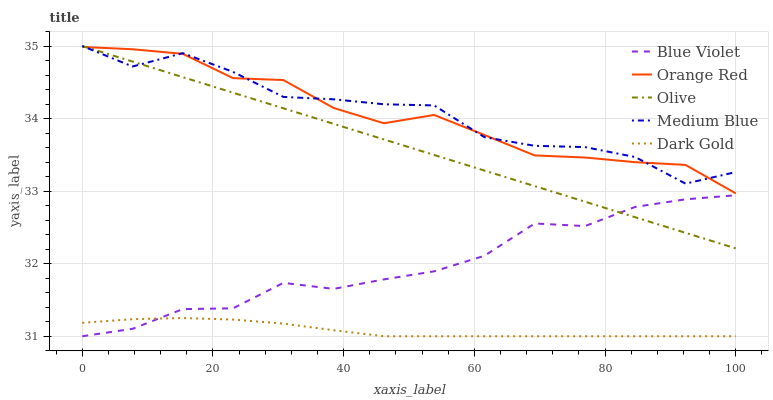Does Orange Red have the minimum area under the curve?
Answer yes or no. No. Does Orange Red have the maximum area under the curve?
Answer yes or no. No. Is Orange Red the smoothest?
Answer yes or no. No. Is Orange Red the roughest?
Answer yes or no. No. Does Orange Red have the lowest value?
Answer yes or no. No. Does Orange Red have the highest value?
Answer yes or no. No. Is Dark Gold less than Medium Blue?
Answer yes or no. Yes. Is Medium Blue greater than Dark Gold?
Answer yes or no. Yes. Does Dark Gold intersect Medium Blue?
Answer yes or no. No. 